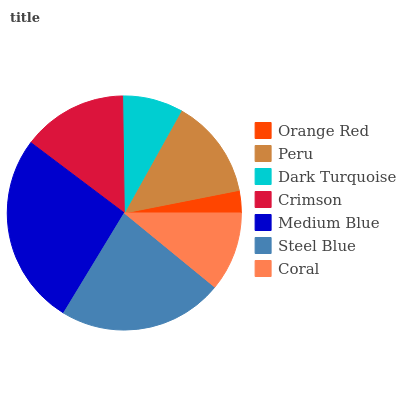Is Orange Red the minimum?
Answer yes or no. Yes. Is Medium Blue the maximum?
Answer yes or no. Yes. Is Peru the minimum?
Answer yes or no. No. Is Peru the maximum?
Answer yes or no. No. Is Peru greater than Orange Red?
Answer yes or no. Yes. Is Orange Red less than Peru?
Answer yes or no. Yes. Is Orange Red greater than Peru?
Answer yes or no. No. Is Peru less than Orange Red?
Answer yes or no. No. Is Peru the high median?
Answer yes or no. Yes. Is Peru the low median?
Answer yes or no. Yes. Is Coral the high median?
Answer yes or no. No. Is Steel Blue the low median?
Answer yes or no. No. 